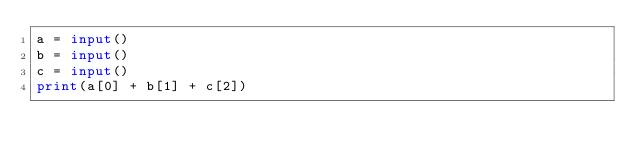<code> <loc_0><loc_0><loc_500><loc_500><_Python_>a = input()
b = input()
c = input()
print(a[0] + b[1] + c[2])</code> 